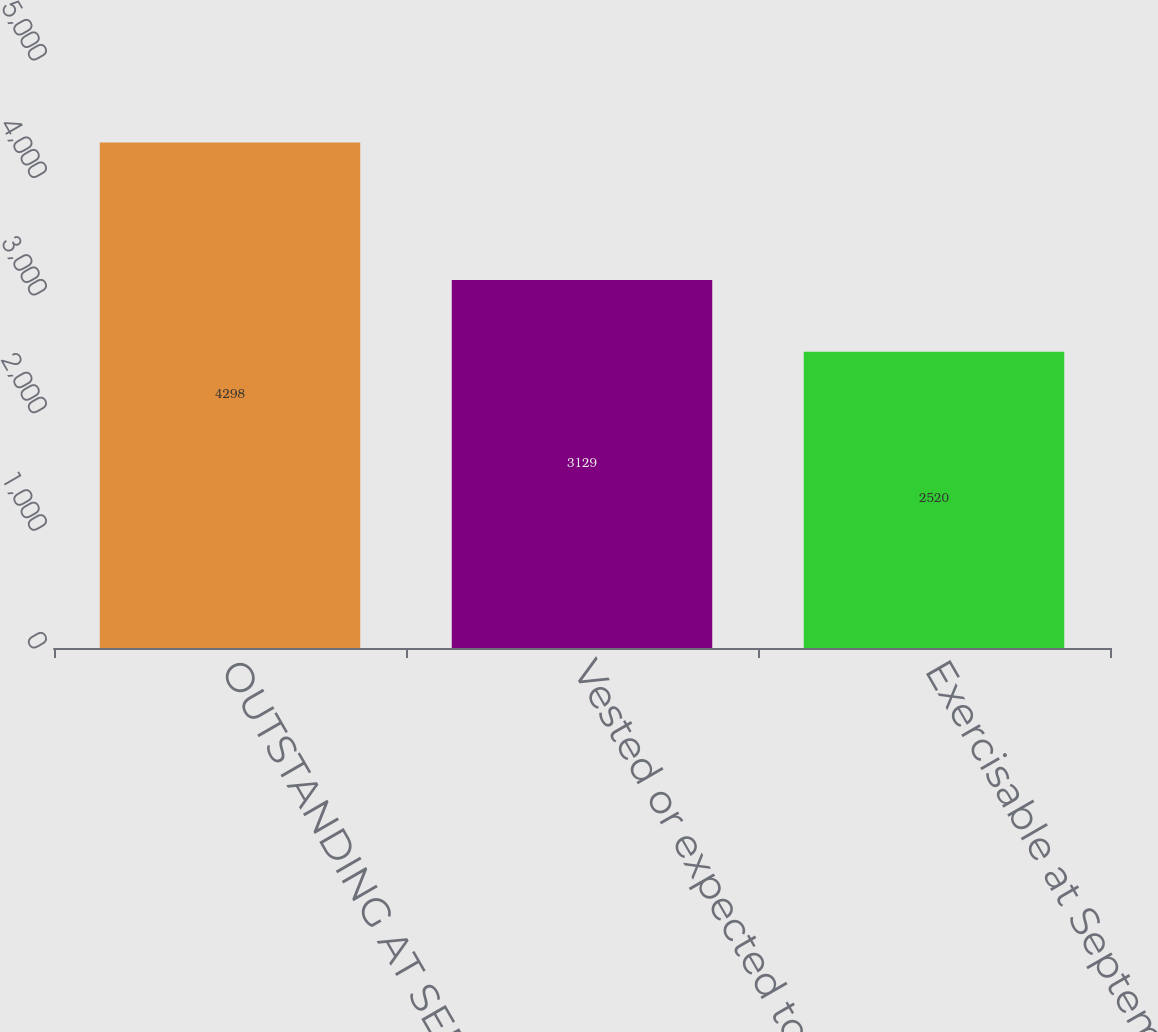Convert chart to OTSL. <chart><loc_0><loc_0><loc_500><loc_500><bar_chart><fcel>OUTSTANDING AT SEPTEMBER 30<fcel>Vested or expected to vest at<fcel>Exercisable at September 30<nl><fcel>4298<fcel>3129<fcel>2520<nl></chart> 